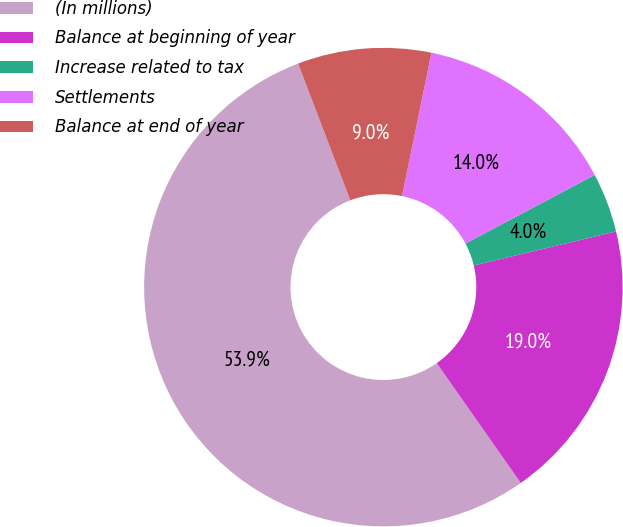Convert chart. <chart><loc_0><loc_0><loc_500><loc_500><pie_chart><fcel>(In millions)<fcel>Balance at beginning of year<fcel>Increase related to tax<fcel>Settlements<fcel>Balance at end of year<nl><fcel>53.93%<fcel>19.0%<fcel>4.03%<fcel>14.01%<fcel>9.02%<nl></chart> 